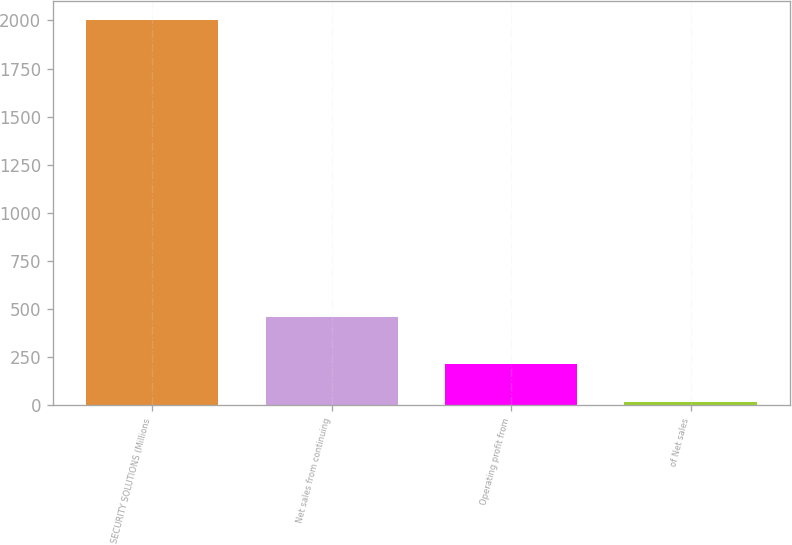Convert chart. <chart><loc_0><loc_0><loc_500><loc_500><bar_chart><fcel>SECURITY SOLUTIONS (Millions<fcel>Net sales from continuing<fcel>Operating profit from<fcel>of Net sales<nl><fcel>2003<fcel>458<fcel>214.7<fcel>16<nl></chart> 